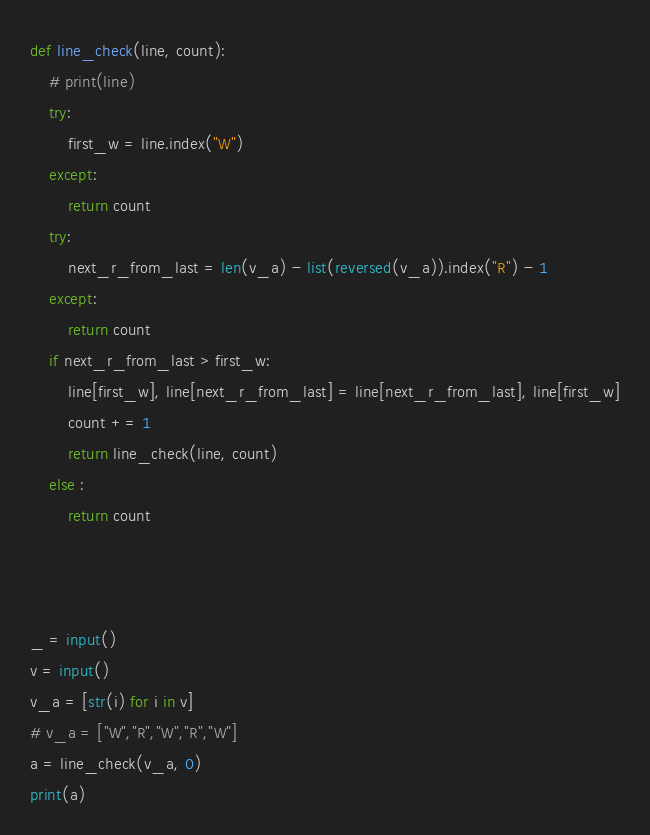Convert code to text. <code><loc_0><loc_0><loc_500><loc_500><_Python_>def line_check(line, count):
    # print(line)
    try:
        first_w = line.index("W")
    except:
        return count
    try:
        next_r_from_last = len(v_a) - list(reversed(v_a)).index("R") - 1
    except:
        return count
    if next_r_from_last > first_w:
        line[first_w], line[next_r_from_last] = line[next_r_from_last], line[first_w]
        count += 1
        return line_check(line, count)
    else :
        return count



_ = input()
v = input()
v_a = [str(i) for i in v]
# v_a = ["W","R","W","R","W"]
a = line_check(v_a, 0)
print(a)



</code> 